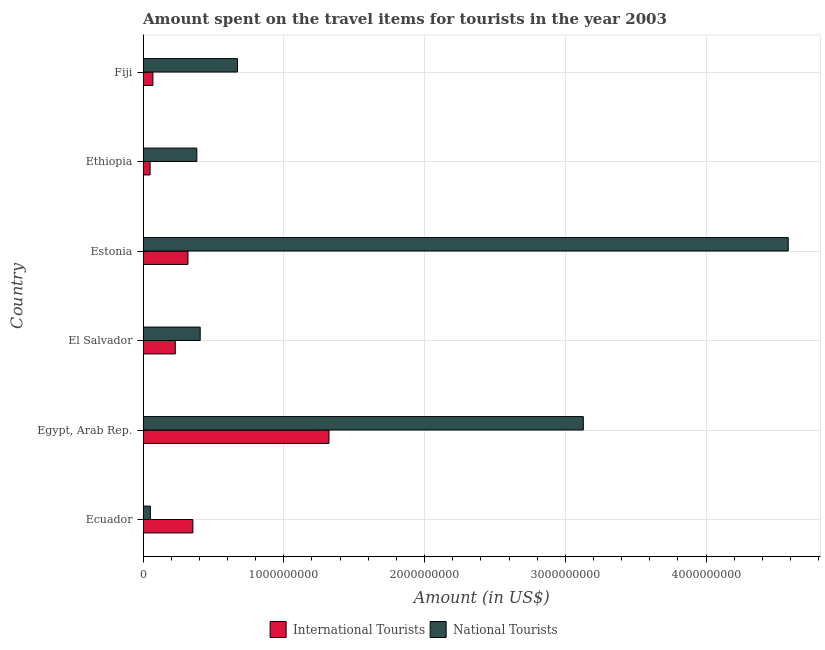How many groups of bars are there?
Give a very brief answer. 6. Are the number of bars per tick equal to the number of legend labels?
Ensure brevity in your answer.  Yes. Are the number of bars on each tick of the Y-axis equal?
Make the answer very short. Yes. How many bars are there on the 5th tick from the top?
Your answer should be compact. 2. How many bars are there on the 4th tick from the bottom?
Provide a succinct answer. 2. What is the label of the 6th group of bars from the top?
Your answer should be very brief. Ecuador. In how many cases, is the number of bars for a given country not equal to the number of legend labels?
Your response must be concise. 0. What is the amount spent on travel items of national tourists in Fiji?
Your response must be concise. 6.71e+08. Across all countries, what is the maximum amount spent on travel items of national tourists?
Your answer should be very brief. 4.58e+09. Across all countries, what is the minimum amount spent on travel items of national tourists?
Give a very brief answer. 5.20e+07. In which country was the amount spent on travel items of national tourists maximum?
Offer a very short reply. Estonia. In which country was the amount spent on travel items of international tourists minimum?
Provide a short and direct response. Ethiopia. What is the total amount spent on travel items of international tourists in the graph?
Offer a very short reply. 2.34e+09. What is the difference between the amount spent on travel items of national tourists in El Salvador and that in Estonia?
Your answer should be compact. -4.18e+09. What is the difference between the amount spent on travel items of international tourists in Ecuador and the amount spent on travel items of national tourists in Egypt, Arab Rep.?
Provide a short and direct response. -2.77e+09. What is the average amount spent on travel items of national tourists per country?
Offer a very short reply. 1.54e+09. What is the difference between the amount spent on travel items of international tourists and amount spent on travel items of national tourists in Estonia?
Your response must be concise. -4.26e+09. In how many countries, is the amount spent on travel items of national tourists greater than 2200000000 US$?
Provide a succinct answer. 2. What is the ratio of the amount spent on travel items of international tourists in Ecuador to that in Ethiopia?
Keep it short and to the point. 7.08. Is the difference between the amount spent on travel items of international tourists in Egypt, Arab Rep. and Fiji greater than the difference between the amount spent on travel items of national tourists in Egypt, Arab Rep. and Fiji?
Keep it short and to the point. No. What is the difference between the highest and the second highest amount spent on travel items of national tourists?
Make the answer very short. 1.46e+09. What is the difference between the highest and the lowest amount spent on travel items of international tourists?
Provide a short and direct response. 1.27e+09. Is the sum of the amount spent on travel items of international tourists in Estonia and Fiji greater than the maximum amount spent on travel items of national tourists across all countries?
Give a very brief answer. No. What does the 2nd bar from the top in Fiji represents?
Provide a short and direct response. International Tourists. What does the 2nd bar from the bottom in Ecuador represents?
Give a very brief answer. National Tourists. Are all the bars in the graph horizontal?
Keep it short and to the point. Yes. What is the difference between two consecutive major ticks on the X-axis?
Your answer should be very brief. 1.00e+09. Are the values on the major ticks of X-axis written in scientific E-notation?
Make the answer very short. No. Does the graph contain grids?
Make the answer very short. Yes. How many legend labels are there?
Your answer should be very brief. 2. What is the title of the graph?
Ensure brevity in your answer.  Amount spent on the travel items for tourists in the year 2003. What is the label or title of the X-axis?
Your response must be concise. Amount (in US$). What is the Amount (in US$) of International Tourists in Ecuador?
Make the answer very short. 3.54e+08. What is the Amount (in US$) in National Tourists in Ecuador?
Offer a terse response. 5.20e+07. What is the Amount (in US$) in International Tourists in Egypt, Arab Rep.?
Make the answer very short. 1.32e+09. What is the Amount (in US$) of National Tourists in Egypt, Arab Rep.?
Offer a very short reply. 3.13e+09. What is the Amount (in US$) of International Tourists in El Salvador?
Make the answer very short. 2.29e+08. What is the Amount (in US$) in National Tourists in El Salvador?
Keep it short and to the point. 4.06e+08. What is the Amount (in US$) in International Tourists in Estonia?
Provide a short and direct response. 3.19e+08. What is the Amount (in US$) in National Tourists in Estonia?
Give a very brief answer. 4.58e+09. What is the Amount (in US$) in National Tourists in Ethiopia?
Provide a succinct answer. 3.82e+08. What is the Amount (in US$) of International Tourists in Fiji?
Your response must be concise. 7.00e+07. What is the Amount (in US$) in National Tourists in Fiji?
Your response must be concise. 6.71e+08. Across all countries, what is the maximum Amount (in US$) in International Tourists?
Your response must be concise. 1.32e+09. Across all countries, what is the maximum Amount (in US$) in National Tourists?
Provide a short and direct response. 4.58e+09. Across all countries, what is the minimum Amount (in US$) in International Tourists?
Your response must be concise. 5.00e+07. Across all countries, what is the minimum Amount (in US$) of National Tourists?
Your answer should be compact. 5.20e+07. What is the total Amount (in US$) in International Tourists in the graph?
Provide a succinct answer. 2.34e+09. What is the total Amount (in US$) in National Tourists in the graph?
Your answer should be compact. 9.22e+09. What is the difference between the Amount (in US$) of International Tourists in Ecuador and that in Egypt, Arab Rep.?
Offer a terse response. -9.67e+08. What is the difference between the Amount (in US$) of National Tourists in Ecuador and that in Egypt, Arab Rep.?
Provide a succinct answer. -3.08e+09. What is the difference between the Amount (in US$) of International Tourists in Ecuador and that in El Salvador?
Keep it short and to the point. 1.25e+08. What is the difference between the Amount (in US$) in National Tourists in Ecuador and that in El Salvador?
Your answer should be very brief. -3.54e+08. What is the difference between the Amount (in US$) in International Tourists in Ecuador and that in Estonia?
Your answer should be compact. 3.50e+07. What is the difference between the Amount (in US$) of National Tourists in Ecuador and that in Estonia?
Keep it short and to the point. -4.53e+09. What is the difference between the Amount (in US$) of International Tourists in Ecuador and that in Ethiopia?
Provide a succinct answer. 3.04e+08. What is the difference between the Amount (in US$) of National Tourists in Ecuador and that in Ethiopia?
Your answer should be compact. -3.30e+08. What is the difference between the Amount (in US$) in International Tourists in Ecuador and that in Fiji?
Provide a short and direct response. 2.84e+08. What is the difference between the Amount (in US$) in National Tourists in Ecuador and that in Fiji?
Keep it short and to the point. -6.19e+08. What is the difference between the Amount (in US$) of International Tourists in Egypt, Arab Rep. and that in El Salvador?
Offer a very short reply. 1.09e+09. What is the difference between the Amount (in US$) of National Tourists in Egypt, Arab Rep. and that in El Salvador?
Make the answer very short. 2.72e+09. What is the difference between the Amount (in US$) in International Tourists in Egypt, Arab Rep. and that in Estonia?
Keep it short and to the point. 1.00e+09. What is the difference between the Amount (in US$) in National Tourists in Egypt, Arab Rep. and that in Estonia?
Make the answer very short. -1.46e+09. What is the difference between the Amount (in US$) of International Tourists in Egypt, Arab Rep. and that in Ethiopia?
Offer a terse response. 1.27e+09. What is the difference between the Amount (in US$) in National Tourists in Egypt, Arab Rep. and that in Ethiopia?
Keep it short and to the point. 2.75e+09. What is the difference between the Amount (in US$) of International Tourists in Egypt, Arab Rep. and that in Fiji?
Your answer should be compact. 1.25e+09. What is the difference between the Amount (in US$) in National Tourists in Egypt, Arab Rep. and that in Fiji?
Ensure brevity in your answer.  2.46e+09. What is the difference between the Amount (in US$) of International Tourists in El Salvador and that in Estonia?
Your answer should be very brief. -9.00e+07. What is the difference between the Amount (in US$) of National Tourists in El Salvador and that in Estonia?
Your response must be concise. -4.18e+09. What is the difference between the Amount (in US$) of International Tourists in El Salvador and that in Ethiopia?
Your answer should be very brief. 1.79e+08. What is the difference between the Amount (in US$) in National Tourists in El Salvador and that in Ethiopia?
Your answer should be very brief. 2.40e+07. What is the difference between the Amount (in US$) in International Tourists in El Salvador and that in Fiji?
Make the answer very short. 1.59e+08. What is the difference between the Amount (in US$) in National Tourists in El Salvador and that in Fiji?
Provide a succinct answer. -2.65e+08. What is the difference between the Amount (in US$) of International Tourists in Estonia and that in Ethiopia?
Ensure brevity in your answer.  2.69e+08. What is the difference between the Amount (in US$) of National Tourists in Estonia and that in Ethiopia?
Keep it short and to the point. 4.20e+09. What is the difference between the Amount (in US$) in International Tourists in Estonia and that in Fiji?
Provide a succinct answer. 2.49e+08. What is the difference between the Amount (in US$) in National Tourists in Estonia and that in Fiji?
Provide a short and direct response. 3.91e+09. What is the difference between the Amount (in US$) in International Tourists in Ethiopia and that in Fiji?
Your answer should be very brief. -2.00e+07. What is the difference between the Amount (in US$) of National Tourists in Ethiopia and that in Fiji?
Provide a succinct answer. -2.89e+08. What is the difference between the Amount (in US$) in International Tourists in Ecuador and the Amount (in US$) in National Tourists in Egypt, Arab Rep.?
Your response must be concise. -2.77e+09. What is the difference between the Amount (in US$) of International Tourists in Ecuador and the Amount (in US$) of National Tourists in El Salvador?
Make the answer very short. -5.20e+07. What is the difference between the Amount (in US$) in International Tourists in Ecuador and the Amount (in US$) in National Tourists in Estonia?
Offer a terse response. -4.23e+09. What is the difference between the Amount (in US$) in International Tourists in Ecuador and the Amount (in US$) in National Tourists in Ethiopia?
Your answer should be compact. -2.80e+07. What is the difference between the Amount (in US$) of International Tourists in Ecuador and the Amount (in US$) of National Tourists in Fiji?
Provide a succinct answer. -3.17e+08. What is the difference between the Amount (in US$) of International Tourists in Egypt, Arab Rep. and the Amount (in US$) of National Tourists in El Salvador?
Provide a succinct answer. 9.15e+08. What is the difference between the Amount (in US$) in International Tourists in Egypt, Arab Rep. and the Amount (in US$) in National Tourists in Estonia?
Your response must be concise. -3.26e+09. What is the difference between the Amount (in US$) in International Tourists in Egypt, Arab Rep. and the Amount (in US$) in National Tourists in Ethiopia?
Your answer should be compact. 9.39e+08. What is the difference between the Amount (in US$) of International Tourists in Egypt, Arab Rep. and the Amount (in US$) of National Tourists in Fiji?
Offer a very short reply. 6.50e+08. What is the difference between the Amount (in US$) in International Tourists in El Salvador and the Amount (in US$) in National Tourists in Estonia?
Provide a succinct answer. -4.36e+09. What is the difference between the Amount (in US$) of International Tourists in El Salvador and the Amount (in US$) of National Tourists in Ethiopia?
Offer a very short reply. -1.53e+08. What is the difference between the Amount (in US$) in International Tourists in El Salvador and the Amount (in US$) in National Tourists in Fiji?
Ensure brevity in your answer.  -4.42e+08. What is the difference between the Amount (in US$) of International Tourists in Estonia and the Amount (in US$) of National Tourists in Ethiopia?
Provide a succinct answer. -6.30e+07. What is the difference between the Amount (in US$) in International Tourists in Estonia and the Amount (in US$) in National Tourists in Fiji?
Keep it short and to the point. -3.52e+08. What is the difference between the Amount (in US$) of International Tourists in Ethiopia and the Amount (in US$) of National Tourists in Fiji?
Keep it short and to the point. -6.21e+08. What is the average Amount (in US$) in International Tourists per country?
Make the answer very short. 3.90e+08. What is the average Amount (in US$) in National Tourists per country?
Provide a short and direct response. 1.54e+09. What is the difference between the Amount (in US$) in International Tourists and Amount (in US$) in National Tourists in Ecuador?
Provide a succinct answer. 3.02e+08. What is the difference between the Amount (in US$) in International Tourists and Amount (in US$) in National Tourists in Egypt, Arab Rep.?
Provide a succinct answer. -1.81e+09. What is the difference between the Amount (in US$) in International Tourists and Amount (in US$) in National Tourists in El Salvador?
Give a very brief answer. -1.77e+08. What is the difference between the Amount (in US$) in International Tourists and Amount (in US$) in National Tourists in Estonia?
Make the answer very short. -4.26e+09. What is the difference between the Amount (in US$) in International Tourists and Amount (in US$) in National Tourists in Ethiopia?
Ensure brevity in your answer.  -3.32e+08. What is the difference between the Amount (in US$) in International Tourists and Amount (in US$) in National Tourists in Fiji?
Offer a very short reply. -6.01e+08. What is the ratio of the Amount (in US$) in International Tourists in Ecuador to that in Egypt, Arab Rep.?
Offer a very short reply. 0.27. What is the ratio of the Amount (in US$) in National Tourists in Ecuador to that in Egypt, Arab Rep.?
Offer a terse response. 0.02. What is the ratio of the Amount (in US$) in International Tourists in Ecuador to that in El Salvador?
Provide a succinct answer. 1.55. What is the ratio of the Amount (in US$) of National Tourists in Ecuador to that in El Salvador?
Offer a very short reply. 0.13. What is the ratio of the Amount (in US$) in International Tourists in Ecuador to that in Estonia?
Provide a succinct answer. 1.11. What is the ratio of the Amount (in US$) of National Tourists in Ecuador to that in Estonia?
Your answer should be very brief. 0.01. What is the ratio of the Amount (in US$) of International Tourists in Ecuador to that in Ethiopia?
Offer a very short reply. 7.08. What is the ratio of the Amount (in US$) in National Tourists in Ecuador to that in Ethiopia?
Keep it short and to the point. 0.14. What is the ratio of the Amount (in US$) in International Tourists in Ecuador to that in Fiji?
Provide a succinct answer. 5.06. What is the ratio of the Amount (in US$) of National Tourists in Ecuador to that in Fiji?
Your answer should be compact. 0.08. What is the ratio of the Amount (in US$) of International Tourists in Egypt, Arab Rep. to that in El Salvador?
Keep it short and to the point. 5.77. What is the ratio of the Amount (in US$) of National Tourists in Egypt, Arab Rep. to that in El Salvador?
Your answer should be compact. 7.7. What is the ratio of the Amount (in US$) in International Tourists in Egypt, Arab Rep. to that in Estonia?
Your answer should be very brief. 4.14. What is the ratio of the Amount (in US$) in National Tourists in Egypt, Arab Rep. to that in Estonia?
Offer a very short reply. 0.68. What is the ratio of the Amount (in US$) of International Tourists in Egypt, Arab Rep. to that in Ethiopia?
Make the answer very short. 26.42. What is the ratio of the Amount (in US$) in National Tourists in Egypt, Arab Rep. to that in Ethiopia?
Your answer should be very brief. 8.19. What is the ratio of the Amount (in US$) of International Tourists in Egypt, Arab Rep. to that in Fiji?
Ensure brevity in your answer.  18.87. What is the ratio of the Amount (in US$) in National Tourists in Egypt, Arab Rep. to that in Fiji?
Keep it short and to the point. 4.66. What is the ratio of the Amount (in US$) in International Tourists in El Salvador to that in Estonia?
Provide a succinct answer. 0.72. What is the ratio of the Amount (in US$) in National Tourists in El Salvador to that in Estonia?
Keep it short and to the point. 0.09. What is the ratio of the Amount (in US$) in International Tourists in El Salvador to that in Ethiopia?
Your response must be concise. 4.58. What is the ratio of the Amount (in US$) of National Tourists in El Salvador to that in Ethiopia?
Provide a short and direct response. 1.06. What is the ratio of the Amount (in US$) of International Tourists in El Salvador to that in Fiji?
Your response must be concise. 3.27. What is the ratio of the Amount (in US$) of National Tourists in El Salvador to that in Fiji?
Keep it short and to the point. 0.61. What is the ratio of the Amount (in US$) of International Tourists in Estonia to that in Ethiopia?
Provide a short and direct response. 6.38. What is the ratio of the Amount (in US$) of International Tourists in Estonia to that in Fiji?
Make the answer very short. 4.56. What is the ratio of the Amount (in US$) of National Tourists in Estonia to that in Fiji?
Keep it short and to the point. 6.83. What is the ratio of the Amount (in US$) in National Tourists in Ethiopia to that in Fiji?
Ensure brevity in your answer.  0.57. What is the difference between the highest and the second highest Amount (in US$) of International Tourists?
Ensure brevity in your answer.  9.67e+08. What is the difference between the highest and the second highest Amount (in US$) in National Tourists?
Ensure brevity in your answer.  1.46e+09. What is the difference between the highest and the lowest Amount (in US$) in International Tourists?
Give a very brief answer. 1.27e+09. What is the difference between the highest and the lowest Amount (in US$) in National Tourists?
Your answer should be compact. 4.53e+09. 